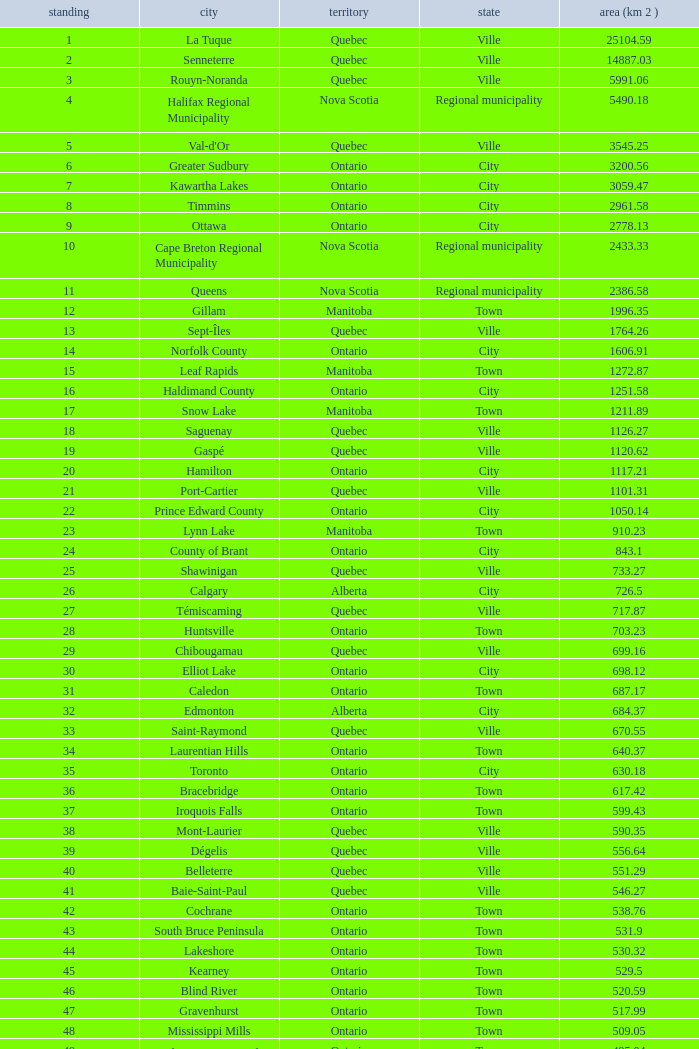What Municipality has a Rank of 44? Lakeshore. 